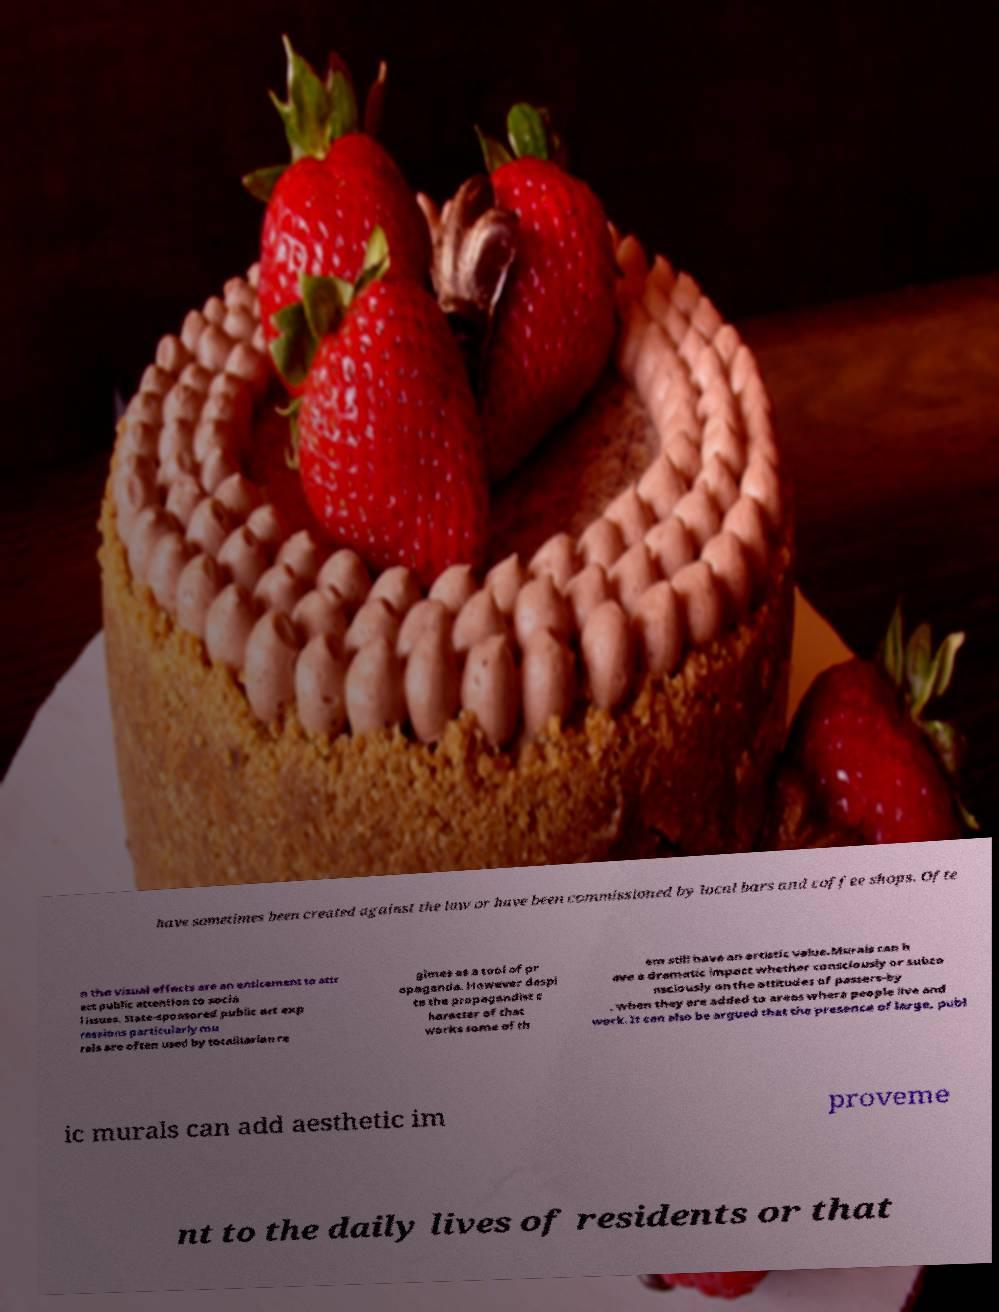Can you accurately transcribe the text from the provided image for me? have sometimes been created against the law or have been commissioned by local bars and coffee shops. Ofte n the visual effects are an enticement to attr act public attention to socia l issues. State-sponsored public art exp ressions particularly mu rals are often used by totalitarian re gimes as a tool of pr opaganda. However despi te the propagandist c haracter of that works some of th em still have an artistic value.Murals can h ave a dramatic impact whether consciously or subco nsciously on the attitudes of passers-by , when they are added to areas where people live and work. It can also be argued that the presence of large, publ ic murals can add aesthetic im proveme nt to the daily lives of residents or that 